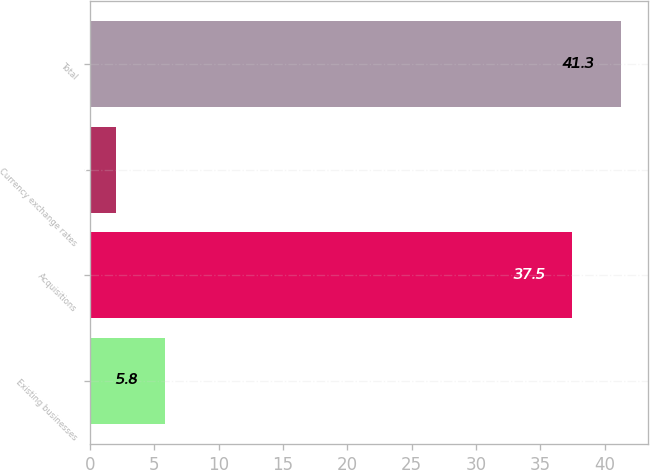Convert chart. <chart><loc_0><loc_0><loc_500><loc_500><bar_chart><fcel>Existing businesses<fcel>Acquisitions<fcel>Currency exchange rates<fcel>Total<nl><fcel>5.8<fcel>37.5<fcel>2<fcel>41.3<nl></chart> 